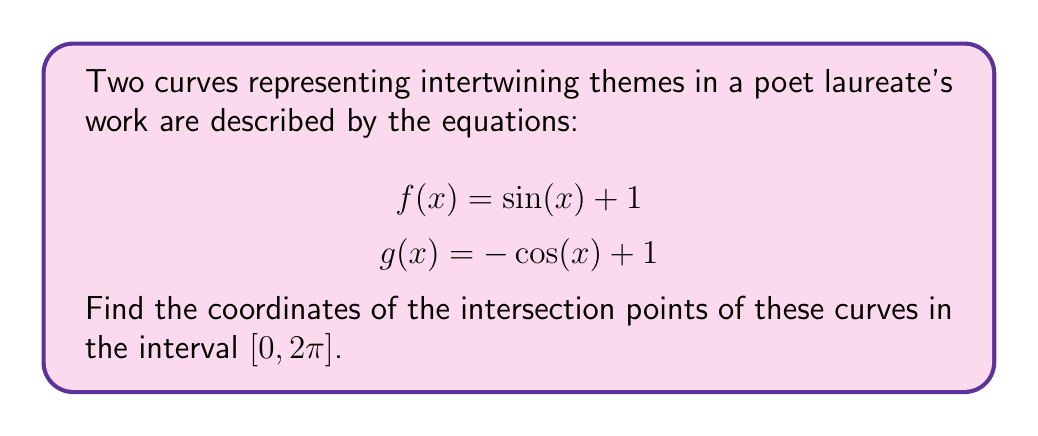Could you help me with this problem? 1) To find the intersection points, we need to solve the equation:
   $$\sin(x) + 1 = -\cos(x) + 1$$

2) Simplify by subtracting 1 from both sides:
   $$\sin(x) = -\cos(x)$$

3) Add $\cos(x)$ to both sides:
   $$\sin(x) + \cos(x) = 0$$

4) Divide both sides by $\sqrt{2}$:
   $$\frac{\sin(x) + \cos(x)}{\sqrt{2}} = 0$$

5) Recognize this as the sine of the sum of angles:
   $$\sin(x + \frac{\pi}{4}) = 0$$

6) The sine function is zero when its argument is a multiple of $\pi$. So:
   $$x + \frac{\pi}{4} = n\pi$$, where $n$ is an integer

7) Solve for $x$:
   $$x = n\pi - \frac{\pi}{4}$$

8) In the interval $[0, 2\pi]$, this equation has two solutions:
   For $n = 1$: $x = \frac{3\pi}{4}$
   For $n = 2$: $x = \frac{7\pi}{4}$

9) To find the y-coordinates, substitute these x-values into either $f(x)$ or $g(x)$:
   At $x = \frac{3\pi}{4}$: $f(\frac{3\pi}{4}) = \sin(\frac{3\pi}{4}) + 1 = \frac{\sqrt{2}}{2} + 1$
   At $x = \frac{7\pi}{4}$: $f(\frac{7\pi}{4}) = \sin(\frac{7\pi}{4}) + 1 = -\frac{\sqrt{2}}{2} + 1$

Therefore, the intersection points are $(\frac{3\pi}{4}, \frac{\sqrt{2}}{2} + 1)$ and $(\frac{7\pi}{4}, -\frac{\sqrt{2}}{2} + 1)$.

[asy]
import graph;
size(200);
real f(real x) {return sin(x)+1;}
real g(real x) {return -cos(x)+1;}
draw(graph(f,0,2*pi),blue);
draw(graph(g,0,2*pi),red);
dot((3*pi/4,sqrt(2)/2+1));
dot((7*pi/4,-sqrt(2)/2+1));
xaxis("x",Arrow);
yaxis("y",Arrow);
label("f(x)",(-0.2,f(0)),W,blue);
label("g(x)",(2*pi,g(2*pi)),E,red);
[/asy]
Answer: $(\frac{3\pi}{4}, \frac{\sqrt{2}}{2} + 1)$ and $(\frac{7\pi}{4}, -\frac{\sqrt{2}}{2} + 1)$ 